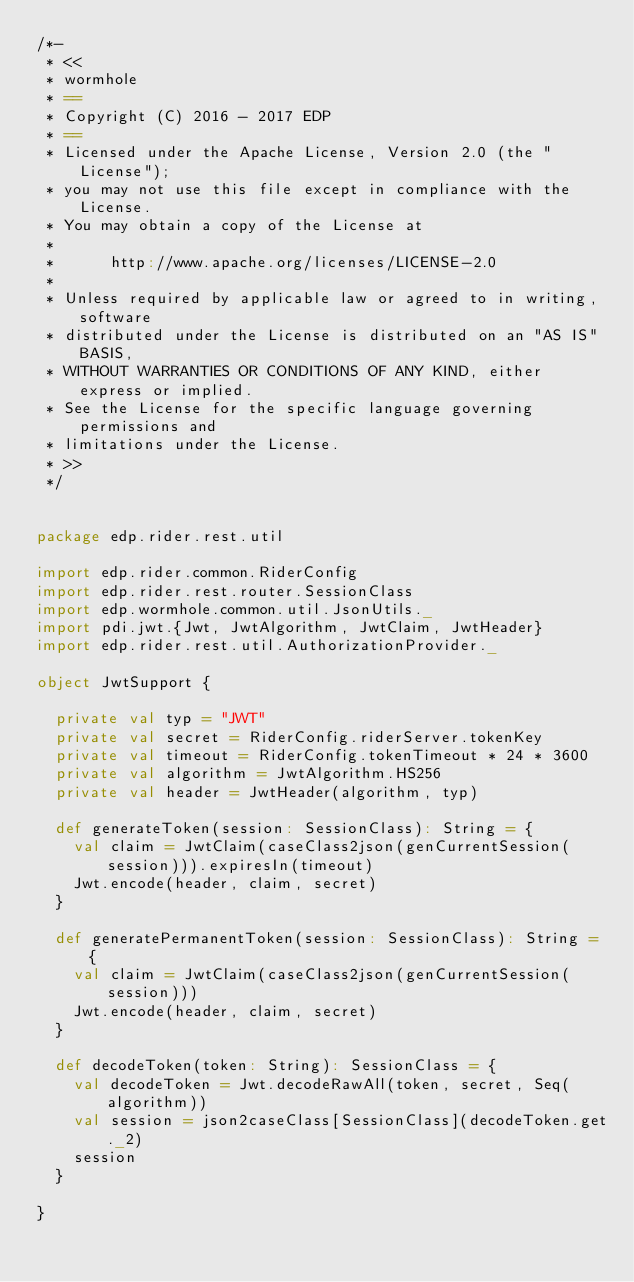Convert code to text. <code><loc_0><loc_0><loc_500><loc_500><_Scala_>/*-
 * <<
 * wormhole
 * ==
 * Copyright (C) 2016 - 2017 EDP
 * ==
 * Licensed under the Apache License, Version 2.0 (the "License");
 * you may not use this file except in compliance with the License.
 * You may obtain a copy of the License at
 * 
 *      http://www.apache.org/licenses/LICENSE-2.0
 * 
 * Unless required by applicable law or agreed to in writing, software
 * distributed under the License is distributed on an "AS IS" BASIS,
 * WITHOUT WARRANTIES OR CONDITIONS OF ANY KIND, either express or implied.
 * See the License for the specific language governing permissions and
 * limitations under the License.
 * >>
 */


package edp.rider.rest.util

import edp.rider.common.RiderConfig
import edp.rider.rest.router.SessionClass
import edp.wormhole.common.util.JsonUtils._
import pdi.jwt.{Jwt, JwtAlgorithm, JwtClaim, JwtHeader}
import edp.rider.rest.util.AuthorizationProvider._

object JwtSupport {

  private val typ = "JWT"
  private val secret = RiderConfig.riderServer.tokenKey
  private val timeout = RiderConfig.tokenTimeout * 24 * 3600
  private val algorithm = JwtAlgorithm.HS256
  private val header = JwtHeader(algorithm, typ)

  def generateToken(session: SessionClass): String = {
    val claim = JwtClaim(caseClass2json(genCurrentSession(session))).expiresIn(timeout)
    Jwt.encode(header, claim, secret)
  }

  def generatePermanentToken(session: SessionClass): String = {
    val claim = JwtClaim(caseClass2json(genCurrentSession(session)))
    Jwt.encode(header, claim, secret)
  }

  def decodeToken(token: String): SessionClass = {
    val decodeToken = Jwt.decodeRawAll(token, secret, Seq(algorithm))
    val session = json2caseClass[SessionClass](decodeToken.get._2)
    session
  }

}
</code> 